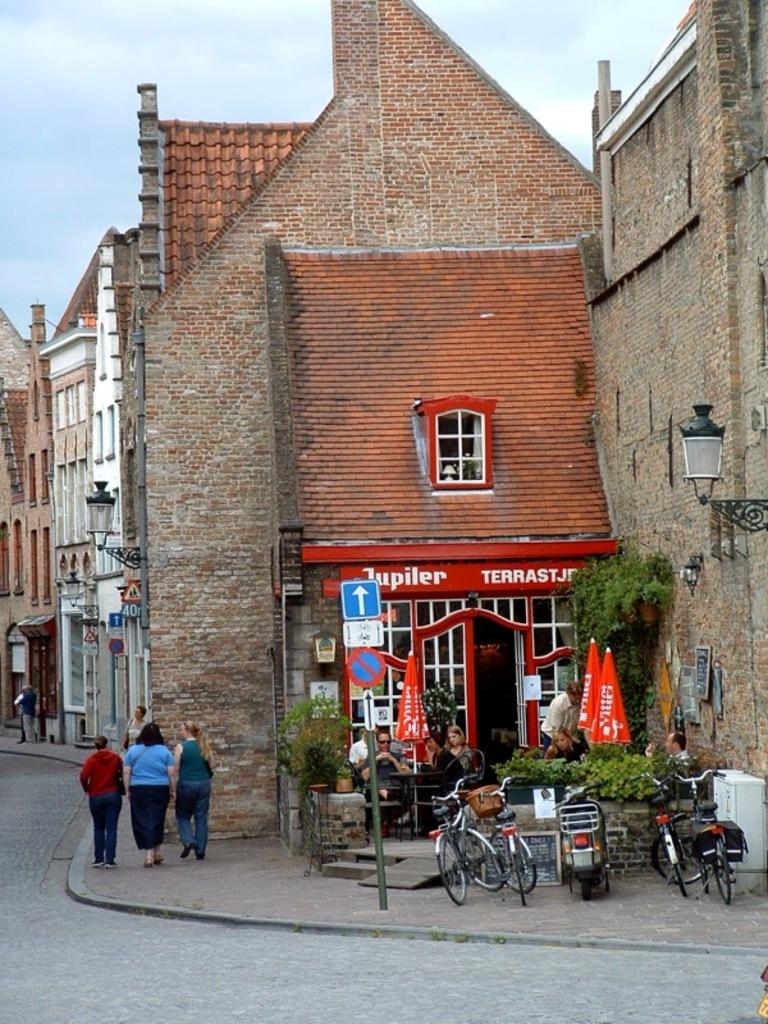<image>
Render a clear and concise summary of the photo. Three people walk outside of a pub called Juputer Terrast. 